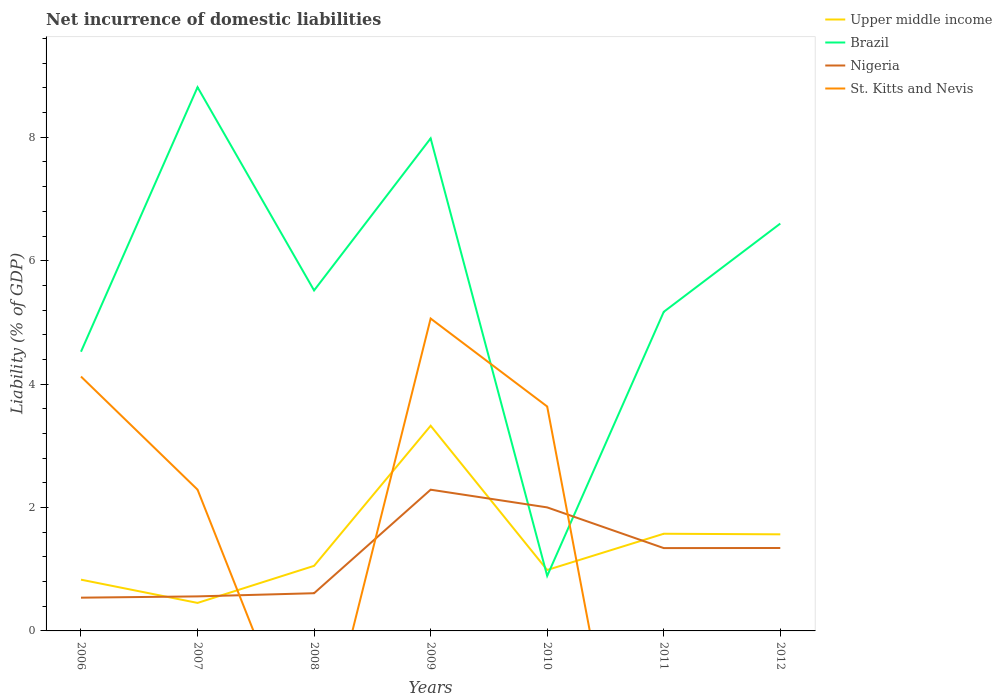Does the line corresponding to Nigeria intersect with the line corresponding to St. Kitts and Nevis?
Make the answer very short. Yes. Across all years, what is the maximum net incurrence of domestic liabilities in Upper middle income?
Offer a very short reply. 0.45. What is the total net incurrence of domestic liabilities in Brazil in the graph?
Provide a short and direct response. -1.08. What is the difference between the highest and the second highest net incurrence of domestic liabilities in Brazil?
Your response must be concise. 7.92. How many lines are there?
Offer a very short reply. 4. What is the difference between two consecutive major ticks on the Y-axis?
Your answer should be compact. 2. Are the values on the major ticks of Y-axis written in scientific E-notation?
Give a very brief answer. No. Does the graph contain grids?
Your answer should be very brief. No. How are the legend labels stacked?
Your answer should be very brief. Vertical. What is the title of the graph?
Ensure brevity in your answer.  Net incurrence of domestic liabilities. Does "Zambia" appear as one of the legend labels in the graph?
Ensure brevity in your answer.  No. What is the label or title of the X-axis?
Offer a terse response. Years. What is the label or title of the Y-axis?
Offer a very short reply. Liability (% of GDP). What is the Liability (% of GDP) of Upper middle income in 2006?
Keep it short and to the point. 0.83. What is the Liability (% of GDP) in Brazil in 2006?
Your response must be concise. 4.53. What is the Liability (% of GDP) in Nigeria in 2006?
Provide a short and direct response. 0.54. What is the Liability (% of GDP) in St. Kitts and Nevis in 2006?
Provide a succinct answer. 4.12. What is the Liability (% of GDP) in Upper middle income in 2007?
Offer a very short reply. 0.45. What is the Liability (% of GDP) of Brazil in 2007?
Keep it short and to the point. 8.81. What is the Liability (% of GDP) of Nigeria in 2007?
Provide a short and direct response. 0.56. What is the Liability (% of GDP) in St. Kitts and Nevis in 2007?
Provide a short and direct response. 2.29. What is the Liability (% of GDP) in Upper middle income in 2008?
Provide a short and direct response. 1.05. What is the Liability (% of GDP) of Brazil in 2008?
Ensure brevity in your answer.  5.52. What is the Liability (% of GDP) in Nigeria in 2008?
Offer a very short reply. 0.61. What is the Liability (% of GDP) of St. Kitts and Nevis in 2008?
Offer a very short reply. 0. What is the Liability (% of GDP) in Upper middle income in 2009?
Offer a terse response. 3.33. What is the Liability (% of GDP) in Brazil in 2009?
Offer a very short reply. 7.98. What is the Liability (% of GDP) in Nigeria in 2009?
Keep it short and to the point. 2.29. What is the Liability (% of GDP) of St. Kitts and Nevis in 2009?
Ensure brevity in your answer.  5.06. What is the Liability (% of GDP) of Upper middle income in 2010?
Offer a very short reply. 0.99. What is the Liability (% of GDP) of Brazil in 2010?
Offer a very short reply. 0.89. What is the Liability (% of GDP) in Nigeria in 2010?
Ensure brevity in your answer.  2. What is the Liability (% of GDP) of St. Kitts and Nevis in 2010?
Your answer should be very brief. 3.64. What is the Liability (% of GDP) of Upper middle income in 2011?
Give a very brief answer. 1.57. What is the Liability (% of GDP) in Brazil in 2011?
Offer a very short reply. 5.17. What is the Liability (% of GDP) in Nigeria in 2011?
Make the answer very short. 1.34. What is the Liability (% of GDP) of St. Kitts and Nevis in 2011?
Provide a succinct answer. 0. What is the Liability (% of GDP) of Upper middle income in 2012?
Provide a succinct answer. 1.57. What is the Liability (% of GDP) in Brazil in 2012?
Offer a very short reply. 6.6. What is the Liability (% of GDP) in Nigeria in 2012?
Provide a short and direct response. 1.34. Across all years, what is the maximum Liability (% of GDP) of Upper middle income?
Your answer should be compact. 3.33. Across all years, what is the maximum Liability (% of GDP) in Brazil?
Your answer should be very brief. 8.81. Across all years, what is the maximum Liability (% of GDP) of Nigeria?
Offer a terse response. 2.29. Across all years, what is the maximum Liability (% of GDP) in St. Kitts and Nevis?
Offer a terse response. 5.06. Across all years, what is the minimum Liability (% of GDP) in Upper middle income?
Make the answer very short. 0.45. Across all years, what is the minimum Liability (% of GDP) of Brazil?
Your response must be concise. 0.89. Across all years, what is the minimum Liability (% of GDP) of Nigeria?
Provide a succinct answer. 0.54. What is the total Liability (% of GDP) in Upper middle income in the graph?
Offer a terse response. 9.79. What is the total Liability (% of GDP) in Brazil in the graph?
Ensure brevity in your answer.  39.5. What is the total Liability (% of GDP) in Nigeria in the graph?
Give a very brief answer. 8.69. What is the total Liability (% of GDP) in St. Kitts and Nevis in the graph?
Your response must be concise. 15.11. What is the difference between the Liability (% of GDP) in Upper middle income in 2006 and that in 2007?
Your answer should be very brief. 0.38. What is the difference between the Liability (% of GDP) of Brazil in 2006 and that in 2007?
Your answer should be compact. -4.29. What is the difference between the Liability (% of GDP) of Nigeria in 2006 and that in 2007?
Give a very brief answer. -0.02. What is the difference between the Liability (% of GDP) in St. Kitts and Nevis in 2006 and that in 2007?
Your response must be concise. 1.83. What is the difference between the Liability (% of GDP) of Upper middle income in 2006 and that in 2008?
Make the answer very short. -0.22. What is the difference between the Liability (% of GDP) of Brazil in 2006 and that in 2008?
Offer a very short reply. -0.99. What is the difference between the Liability (% of GDP) in Nigeria in 2006 and that in 2008?
Provide a short and direct response. -0.07. What is the difference between the Liability (% of GDP) in Upper middle income in 2006 and that in 2009?
Offer a terse response. -2.49. What is the difference between the Liability (% of GDP) in Brazil in 2006 and that in 2009?
Give a very brief answer. -3.46. What is the difference between the Liability (% of GDP) in Nigeria in 2006 and that in 2009?
Offer a very short reply. -1.75. What is the difference between the Liability (% of GDP) of St. Kitts and Nevis in 2006 and that in 2009?
Your answer should be compact. -0.94. What is the difference between the Liability (% of GDP) of Upper middle income in 2006 and that in 2010?
Give a very brief answer. -0.16. What is the difference between the Liability (% of GDP) in Brazil in 2006 and that in 2010?
Your answer should be very brief. 3.63. What is the difference between the Liability (% of GDP) of Nigeria in 2006 and that in 2010?
Offer a terse response. -1.46. What is the difference between the Liability (% of GDP) of St. Kitts and Nevis in 2006 and that in 2010?
Your answer should be compact. 0.49. What is the difference between the Liability (% of GDP) in Upper middle income in 2006 and that in 2011?
Offer a very short reply. -0.74. What is the difference between the Liability (% of GDP) in Brazil in 2006 and that in 2011?
Offer a very short reply. -0.65. What is the difference between the Liability (% of GDP) in Nigeria in 2006 and that in 2011?
Your response must be concise. -0.8. What is the difference between the Liability (% of GDP) in Upper middle income in 2006 and that in 2012?
Provide a short and direct response. -0.73. What is the difference between the Liability (% of GDP) in Brazil in 2006 and that in 2012?
Ensure brevity in your answer.  -2.08. What is the difference between the Liability (% of GDP) of Nigeria in 2006 and that in 2012?
Give a very brief answer. -0.81. What is the difference between the Liability (% of GDP) in Upper middle income in 2007 and that in 2008?
Make the answer very short. -0.6. What is the difference between the Liability (% of GDP) of Brazil in 2007 and that in 2008?
Ensure brevity in your answer.  3.29. What is the difference between the Liability (% of GDP) of Nigeria in 2007 and that in 2008?
Offer a terse response. -0.05. What is the difference between the Liability (% of GDP) in Upper middle income in 2007 and that in 2009?
Your response must be concise. -2.87. What is the difference between the Liability (% of GDP) in Brazil in 2007 and that in 2009?
Provide a succinct answer. 0.83. What is the difference between the Liability (% of GDP) of Nigeria in 2007 and that in 2009?
Your answer should be very brief. -1.73. What is the difference between the Liability (% of GDP) in St. Kitts and Nevis in 2007 and that in 2009?
Your answer should be very brief. -2.77. What is the difference between the Liability (% of GDP) of Upper middle income in 2007 and that in 2010?
Your answer should be very brief. -0.53. What is the difference between the Liability (% of GDP) of Brazil in 2007 and that in 2010?
Give a very brief answer. 7.92. What is the difference between the Liability (% of GDP) in Nigeria in 2007 and that in 2010?
Provide a succinct answer. -1.44. What is the difference between the Liability (% of GDP) of St. Kitts and Nevis in 2007 and that in 2010?
Provide a succinct answer. -1.35. What is the difference between the Liability (% of GDP) of Upper middle income in 2007 and that in 2011?
Make the answer very short. -1.12. What is the difference between the Liability (% of GDP) in Brazil in 2007 and that in 2011?
Your answer should be compact. 3.64. What is the difference between the Liability (% of GDP) of Nigeria in 2007 and that in 2011?
Keep it short and to the point. -0.78. What is the difference between the Liability (% of GDP) in Upper middle income in 2007 and that in 2012?
Make the answer very short. -1.11. What is the difference between the Liability (% of GDP) in Brazil in 2007 and that in 2012?
Offer a terse response. 2.21. What is the difference between the Liability (% of GDP) in Nigeria in 2007 and that in 2012?
Make the answer very short. -0.78. What is the difference between the Liability (% of GDP) in Upper middle income in 2008 and that in 2009?
Your answer should be very brief. -2.27. What is the difference between the Liability (% of GDP) in Brazil in 2008 and that in 2009?
Your answer should be very brief. -2.46. What is the difference between the Liability (% of GDP) of Nigeria in 2008 and that in 2009?
Your answer should be compact. -1.68. What is the difference between the Liability (% of GDP) of Upper middle income in 2008 and that in 2010?
Give a very brief answer. 0.07. What is the difference between the Liability (% of GDP) in Brazil in 2008 and that in 2010?
Offer a terse response. 4.63. What is the difference between the Liability (% of GDP) of Nigeria in 2008 and that in 2010?
Ensure brevity in your answer.  -1.39. What is the difference between the Liability (% of GDP) of Upper middle income in 2008 and that in 2011?
Your response must be concise. -0.52. What is the difference between the Liability (% of GDP) of Brazil in 2008 and that in 2011?
Provide a succinct answer. 0.35. What is the difference between the Liability (% of GDP) of Nigeria in 2008 and that in 2011?
Offer a terse response. -0.73. What is the difference between the Liability (% of GDP) of Upper middle income in 2008 and that in 2012?
Your answer should be compact. -0.51. What is the difference between the Liability (% of GDP) of Brazil in 2008 and that in 2012?
Provide a succinct answer. -1.08. What is the difference between the Liability (% of GDP) of Nigeria in 2008 and that in 2012?
Give a very brief answer. -0.73. What is the difference between the Liability (% of GDP) in Upper middle income in 2009 and that in 2010?
Provide a short and direct response. 2.34. What is the difference between the Liability (% of GDP) of Brazil in 2009 and that in 2010?
Provide a short and direct response. 7.09. What is the difference between the Liability (% of GDP) of Nigeria in 2009 and that in 2010?
Provide a succinct answer. 0.29. What is the difference between the Liability (% of GDP) in St. Kitts and Nevis in 2009 and that in 2010?
Your answer should be very brief. 1.43. What is the difference between the Liability (% of GDP) in Upper middle income in 2009 and that in 2011?
Ensure brevity in your answer.  1.75. What is the difference between the Liability (% of GDP) in Brazil in 2009 and that in 2011?
Offer a terse response. 2.81. What is the difference between the Liability (% of GDP) in Nigeria in 2009 and that in 2011?
Give a very brief answer. 0.95. What is the difference between the Liability (% of GDP) in Upper middle income in 2009 and that in 2012?
Make the answer very short. 1.76. What is the difference between the Liability (% of GDP) in Brazil in 2009 and that in 2012?
Your answer should be very brief. 1.38. What is the difference between the Liability (% of GDP) in Nigeria in 2009 and that in 2012?
Make the answer very short. 0.94. What is the difference between the Liability (% of GDP) in Upper middle income in 2010 and that in 2011?
Provide a succinct answer. -0.59. What is the difference between the Liability (% of GDP) of Brazil in 2010 and that in 2011?
Ensure brevity in your answer.  -4.28. What is the difference between the Liability (% of GDP) of Nigeria in 2010 and that in 2011?
Make the answer very short. 0.66. What is the difference between the Liability (% of GDP) of Upper middle income in 2010 and that in 2012?
Make the answer very short. -0.58. What is the difference between the Liability (% of GDP) of Brazil in 2010 and that in 2012?
Offer a terse response. -5.71. What is the difference between the Liability (% of GDP) in Nigeria in 2010 and that in 2012?
Your response must be concise. 0.66. What is the difference between the Liability (% of GDP) in Upper middle income in 2011 and that in 2012?
Your response must be concise. 0.01. What is the difference between the Liability (% of GDP) of Brazil in 2011 and that in 2012?
Offer a very short reply. -1.43. What is the difference between the Liability (% of GDP) in Nigeria in 2011 and that in 2012?
Keep it short and to the point. -0. What is the difference between the Liability (% of GDP) of Upper middle income in 2006 and the Liability (% of GDP) of Brazil in 2007?
Keep it short and to the point. -7.98. What is the difference between the Liability (% of GDP) of Upper middle income in 2006 and the Liability (% of GDP) of Nigeria in 2007?
Keep it short and to the point. 0.27. What is the difference between the Liability (% of GDP) of Upper middle income in 2006 and the Liability (% of GDP) of St. Kitts and Nevis in 2007?
Provide a short and direct response. -1.46. What is the difference between the Liability (% of GDP) in Brazil in 2006 and the Liability (% of GDP) in Nigeria in 2007?
Keep it short and to the point. 3.97. What is the difference between the Liability (% of GDP) in Brazil in 2006 and the Liability (% of GDP) in St. Kitts and Nevis in 2007?
Provide a succinct answer. 2.24. What is the difference between the Liability (% of GDP) of Nigeria in 2006 and the Liability (% of GDP) of St. Kitts and Nevis in 2007?
Provide a succinct answer. -1.75. What is the difference between the Liability (% of GDP) in Upper middle income in 2006 and the Liability (% of GDP) in Brazil in 2008?
Keep it short and to the point. -4.69. What is the difference between the Liability (% of GDP) in Upper middle income in 2006 and the Liability (% of GDP) in Nigeria in 2008?
Keep it short and to the point. 0.22. What is the difference between the Liability (% of GDP) of Brazil in 2006 and the Liability (% of GDP) of Nigeria in 2008?
Offer a terse response. 3.91. What is the difference between the Liability (% of GDP) in Upper middle income in 2006 and the Liability (% of GDP) in Brazil in 2009?
Offer a very short reply. -7.15. What is the difference between the Liability (% of GDP) of Upper middle income in 2006 and the Liability (% of GDP) of Nigeria in 2009?
Ensure brevity in your answer.  -1.46. What is the difference between the Liability (% of GDP) in Upper middle income in 2006 and the Liability (% of GDP) in St. Kitts and Nevis in 2009?
Give a very brief answer. -4.23. What is the difference between the Liability (% of GDP) in Brazil in 2006 and the Liability (% of GDP) in Nigeria in 2009?
Provide a short and direct response. 2.24. What is the difference between the Liability (% of GDP) in Brazil in 2006 and the Liability (% of GDP) in St. Kitts and Nevis in 2009?
Provide a short and direct response. -0.54. What is the difference between the Liability (% of GDP) of Nigeria in 2006 and the Liability (% of GDP) of St. Kitts and Nevis in 2009?
Offer a very short reply. -4.52. What is the difference between the Liability (% of GDP) in Upper middle income in 2006 and the Liability (% of GDP) in Brazil in 2010?
Your response must be concise. -0.06. What is the difference between the Liability (% of GDP) of Upper middle income in 2006 and the Liability (% of GDP) of Nigeria in 2010?
Provide a succinct answer. -1.17. What is the difference between the Liability (% of GDP) of Upper middle income in 2006 and the Liability (% of GDP) of St. Kitts and Nevis in 2010?
Provide a succinct answer. -2.81. What is the difference between the Liability (% of GDP) in Brazil in 2006 and the Liability (% of GDP) in Nigeria in 2010?
Provide a short and direct response. 2.52. What is the difference between the Liability (% of GDP) of Brazil in 2006 and the Liability (% of GDP) of St. Kitts and Nevis in 2010?
Provide a short and direct response. 0.89. What is the difference between the Liability (% of GDP) of Nigeria in 2006 and the Liability (% of GDP) of St. Kitts and Nevis in 2010?
Your answer should be compact. -3.1. What is the difference between the Liability (% of GDP) of Upper middle income in 2006 and the Liability (% of GDP) of Brazil in 2011?
Provide a short and direct response. -4.34. What is the difference between the Liability (% of GDP) of Upper middle income in 2006 and the Liability (% of GDP) of Nigeria in 2011?
Your response must be concise. -0.51. What is the difference between the Liability (% of GDP) in Brazil in 2006 and the Liability (% of GDP) in Nigeria in 2011?
Your answer should be very brief. 3.18. What is the difference between the Liability (% of GDP) in Upper middle income in 2006 and the Liability (% of GDP) in Brazil in 2012?
Your answer should be compact. -5.77. What is the difference between the Liability (% of GDP) of Upper middle income in 2006 and the Liability (% of GDP) of Nigeria in 2012?
Keep it short and to the point. -0.51. What is the difference between the Liability (% of GDP) of Brazil in 2006 and the Liability (% of GDP) of Nigeria in 2012?
Offer a terse response. 3.18. What is the difference between the Liability (% of GDP) of Upper middle income in 2007 and the Liability (% of GDP) of Brazil in 2008?
Provide a short and direct response. -5.06. What is the difference between the Liability (% of GDP) of Upper middle income in 2007 and the Liability (% of GDP) of Nigeria in 2008?
Make the answer very short. -0.16. What is the difference between the Liability (% of GDP) of Brazil in 2007 and the Liability (% of GDP) of Nigeria in 2008?
Provide a short and direct response. 8.2. What is the difference between the Liability (% of GDP) of Upper middle income in 2007 and the Liability (% of GDP) of Brazil in 2009?
Keep it short and to the point. -7.53. What is the difference between the Liability (% of GDP) of Upper middle income in 2007 and the Liability (% of GDP) of Nigeria in 2009?
Keep it short and to the point. -1.83. What is the difference between the Liability (% of GDP) of Upper middle income in 2007 and the Liability (% of GDP) of St. Kitts and Nevis in 2009?
Keep it short and to the point. -4.61. What is the difference between the Liability (% of GDP) in Brazil in 2007 and the Liability (% of GDP) in Nigeria in 2009?
Make the answer very short. 6.52. What is the difference between the Liability (% of GDP) of Brazil in 2007 and the Liability (% of GDP) of St. Kitts and Nevis in 2009?
Give a very brief answer. 3.75. What is the difference between the Liability (% of GDP) in Nigeria in 2007 and the Liability (% of GDP) in St. Kitts and Nevis in 2009?
Give a very brief answer. -4.5. What is the difference between the Liability (% of GDP) in Upper middle income in 2007 and the Liability (% of GDP) in Brazil in 2010?
Ensure brevity in your answer.  -0.44. What is the difference between the Liability (% of GDP) of Upper middle income in 2007 and the Liability (% of GDP) of Nigeria in 2010?
Your answer should be very brief. -1.55. What is the difference between the Liability (% of GDP) of Upper middle income in 2007 and the Liability (% of GDP) of St. Kitts and Nevis in 2010?
Make the answer very short. -3.18. What is the difference between the Liability (% of GDP) of Brazil in 2007 and the Liability (% of GDP) of Nigeria in 2010?
Keep it short and to the point. 6.81. What is the difference between the Liability (% of GDP) in Brazil in 2007 and the Liability (% of GDP) in St. Kitts and Nevis in 2010?
Keep it short and to the point. 5.17. What is the difference between the Liability (% of GDP) in Nigeria in 2007 and the Liability (% of GDP) in St. Kitts and Nevis in 2010?
Your answer should be very brief. -3.08. What is the difference between the Liability (% of GDP) of Upper middle income in 2007 and the Liability (% of GDP) of Brazil in 2011?
Provide a short and direct response. -4.72. What is the difference between the Liability (% of GDP) of Upper middle income in 2007 and the Liability (% of GDP) of Nigeria in 2011?
Ensure brevity in your answer.  -0.89. What is the difference between the Liability (% of GDP) of Brazil in 2007 and the Liability (% of GDP) of Nigeria in 2011?
Your answer should be very brief. 7.47. What is the difference between the Liability (% of GDP) of Upper middle income in 2007 and the Liability (% of GDP) of Brazil in 2012?
Give a very brief answer. -6.15. What is the difference between the Liability (% of GDP) of Upper middle income in 2007 and the Liability (% of GDP) of Nigeria in 2012?
Give a very brief answer. -0.89. What is the difference between the Liability (% of GDP) in Brazil in 2007 and the Liability (% of GDP) in Nigeria in 2012?
Keep it short and to the point. 7.47. What is the difference between the Liability (% of GDP) in Upper middle income in 2008 and the Liability (% of GDP) in Brazil in 2009?
Your answer should be very brief. -6.93. What is the difference between the Liability (% of GDP) in Upper middle income in 2008 and the Liability (% of GDP) in Nigeria in 2009?
Offer a terse response. -1.23. What is the difference between the Liability (% of GDP) of Upper middle income in 2008 and the Liability (% of GDP) of St. Kitts and Nevis in 2009?
Offer a terse response. -4.01. What is the difference between the Liability (% of GDP) in Brazil in 2008 and the Liability (% of GDP) in Nigeria in 2009?
Give a very brief answer. 3.23. What is the difference between the Liability (% of GDP) of Brazil in 2008 and the Liability (% of GDP) of St. Kitts and Nevis in 2009?
Keep it short and to the point. 0.46. What is the difference between the Liability (% of GDP) in Nigeria in 2008 and the Liability (% of GDP) in St. Kitts and Nevis in 2009?
Offer a terse response. -4.45. What is the difference between the Liability (% of GDP) in Upper middle income in 2008 and the Liability (% of GDP) in Brazil in 2010?
Offer a terse response. 0.16. What is the difference between the Liability (% of GDP) in Upper middle income in 2008 and the Liability (% of GDP) in Nigeria in 2010?
Your response must be concise. -0.95. What is the difference between the Liability (% of GDP) of Upper middle income in 2008 and the Liability (% of GDP) of St. Kitts and Nevis in 2010?
Make the answer very short. -2.58. What is the difference between the Liability (% of GDP) of Brazil in 2008 and the Liability (% of GDP) of Nigeria in 2010?
Give a very brief answer. 3.52. What is the difference between the Liability (% of GDP) in Brazil in 2008 and the Liability (% of GDP) in St. Kitts and Nevis in 2010?
Provide a succinct answer. 1.88. What is the difference between the Liability (% of GDP) in Nigeria in 2008 and the Liability (% of GDP) in St. Kitts and Nevis in 2010?
Your response must be concise. -3.03. What is the difference between the Liability (% of GDP) of Upper middle income in 2008 and the Liability (% of GDP) of Brazil in 2011?
Your answer should be compact. -4.12. What is the difference between the Liability (% of GDP) in Upper middle income in 2008 and the Liability (% of GDP) in Nigeria in 2011?
Your answer should be compact. -0.29. What is the difference between the Liability (% of GDP) in Brazil in 2008 and the Liability (% of GDP) in Nigeria in 2011?
Give a very brief answer. 4.18. What is the difference between the Liability (% of GDP) in Upper middle income in 2008 and the Liability (% of GDP) in Brazil in 2012?
Provide a succinct answer. -5.55. What is the difference between the Liability (% of GDP) of Upper middle income in 2008 and the Liability (% of GDP) of Nigeria in 2012?
Your answer should be compact. -0.29. What is the difference between the Liability (% of GDP) in Brazil in 2008 and the Liability (% of GDP) in Nigeria in 2012?
Ensure brevity in your answer.  4.17. What is the difference between the Liability (% of GDP) in Upper middle income in 2009 and the Liability (% of GDP) in Brazil in 2010?
Offer a very short reply. 2.43. What is the difference between the Liability (% of GDP) in Upper middle income in 2009 and the Liability (% of GDP) in Nigeria in 2010?
Provide a succinct answer. 1.32. What is the difference between the Liability (% of GDP) of Upper middle income in 2009 and the Liability (% of GDP) of St. Kitts and Nevis in 2010?
Provide a succinct answer. -0.31. What is the difference between the Liability (% of GDP) in Brazil in 2009 and the Liability (% of GDP) in Nigeria in 2010?
Keep it short and to the point. 5.98. What is the difference between the Liability (% of GDP) of Brazil in 2009 and the Liability (% of GDP) of St. Kitts and Nevis in 2010?
Your answer should be compact. 4.35. What is the difference between the Liability (% of GDP) of Nigeria in 2009 and the Liability (% of GDP) of St. Kitts and Nevis in 2010?
Provide a short and direct response. -1.35. What is the difference between the Liability (% of GDP) in Upper middle income in 2009 and the Liability (% of GDP) in Brazil in 2011?
Your answer should be compact. -1.85. What is the difference between the Liability (% of GDP) in Upper middle income in 2009 and the Liability (% of GDP) in Nigeria in 2011?
Your response must be concise. 1.98. What is the difference between the Liability (% of GDP) in Brazil in 2009 and the Liability (% of GDP) in Nigeria in 2011?
Keep it short and to the point. 6.64. What is the difference between the Liability (% of GDP) of Upper middle income in 2009 and the Liability (% of GDP) of Brazil in 2012?
Your response must be concise. -3.28. What is the difference between the Liability (% of GDP) in Upper middle income in 2009 and the Liability (% of GDP) in Nigeria in 2012?
Your answer should be very brief. 1.98. What is the difference between the Liability (% of GDP) in Brazil in 2009 and the Liability (% of GDP) in Nigeria in 2012?
Keep it short and to the point. 6.64. What is the difference between the Liability (% of GDP) of Upper middle income in 2010 and the Liability (% of GDP) of Brazil in 2011?
Provide a succinct answer. -4.18. What is the difference between the Liability (% of GDP) of Upper middle income in 2010 and the Liability (% of GDP) of Nigeria in 2011?
Make the answer very short. -0.35. What is the difference between the Liability (% of GDP) of Brazil in 2010 and the Liability (% of GDP) of Nigeria in 2011?
Give a very brief answer. -0.45. What is the difference between the Liability (% of GDP) of Upper middle income in 2010 and the Liability (% of GDP) of Brazil in 2012?
Offer a terse response. -5.61. What is the difference between the Liability (% of GDP) of Upper middle income in 2010 and the Liability (% of GDP) of Nigeria in 2012?
Your answer should be very brief. -0.36. What is the difference between the Liability (% of GDP) of Brazil in 2010 and the Liability (% of GDP) of Nigeria in 2012?
Make the answer very short. -0.45. What is the difference between the Liability (% of GDP) of Upper middle income in 2011 and the Liability (% of GDP) of Brazil in 2012?
Offer a terse response. -5.03. What is the difference between the Liability (% of GDP) in Upper middle income in 2011 and the Liability (% of GDP) in Nigeria in 2012?
Offer a very short reply. 0.23. What is the difference between the Liability (% of GDP) in Brazil in 2011 and the Liability (% of GDP) in Nigeria in 2012?
Your answer should be compact. 3.83. What is the average Liability (% of GDP) of Upper middle income per year?
Keep it short and to the point. 1.4. What is the average Liability (% of GDP) in Brazil per year?
Make the answer very short. 5.64. What is the average Liability (% of GDP) of Nigeria per year?
Make the answer very short. 1.24. What is the average Liability (% of GDP) in St. Kitts and Nevis per year?
Provide a succinct answer. 2.16. In the year 2006, what is the difference between the Liability (% of GDP) of Upper middle income and Liability (% of GDP) of Brazil?
Your response must be concise. -3.69. In the year 2006, what is the difference between the Liability (% of GDP) in Upper middle income and Liability (% of GDP) in Nigeria?
Offer a terse response. 0.29. In the year 2006, what is the difference between the Liability (% of GDP) of Upper middle income and Liability (% of GDP) of St. Kitts and Nevis?
Your answer should be compact. -3.29. In the year 2006, what is the difference between the Liability (% of GDP) of Brazil and Liability (% of GDP) of Nigeria?
Provide a short and direct response. 3.99. In the year 2006, what is the difference between the Liability (% of GDP) of Brazil and Liability (% of GDP) of St. Kitts and Nevis?
Your response must be concise. 0.4. In the year 2006, what is the difference between the Liability (% of GDP) in Nigeria and Liability (% of GDP) in St. Kitts and Nevis?
Keep it short and to the point. -3.58. In the year 2007, what is the difference between the Liability (% of GDP) in Upper middle income and Liability (% of GDP) in Brazil?
Offer a terse response. -8.36. In the year 2007, what is the difference between the Liability (% of GDP) in Upper middle income and Liability (% of GDP) in Nigeria?
Provide a succinct answer. -0.11. In the year 2007, what is the difference between the Liability (% of GDP) of Upper middle income and Liability (% of GDP) of St. Kitts and Nevis?
Your answer should be compact. -1.84. In the year 2007, what is the difference between the Liability (% of GDP) in Brazil and Liability (% of GDP) in Nigeria?
Keep it short and to the point. 8.25. In the year 2007, what is the difference between the Liability (% of GDP) of Brazil and Liability (% of GDP) of St. Kitts and Nevis?
Make the answer very short. 6.52. In the year 2007, what is the difference between the Liability (% of GDP) of Nigeria and Liability (% of GDP) of St. Kitts and Nevis?
Provide a succinct answer. -1.73. In the year 2008, what is the difference between the Liability (% of GDP) in Upper middle income and Liability (% of GDP) in Brazil?
Provide a short and direct response. -4.46. In the year 2008, what is the difference between the Liability (% of GDP) of Upper middle income and Liability (% of GDP) of Nigeria?
Give a very brief answer. 0.44. In the year 2008, what is the difference between the Liability (% of GDP) of Brazil and Liability (% of GDP) of Nigeria?
Give a very brief answer. 4.91. In the year 2009, what is the difference between the Liability (% of GDP) of Upper middle income and Liability (% of GDP) of Brazil?
Offer a terse response. -4.66. In the year 2009, what is the difference between the Liability (% of GDP) of Upper middle income and Liability (% of GDP) of Nigeria?
Make the answer very short. 1.04. In the year 2009, what is the difference between the Liability (% of GDP) in Upper middle income and Liability (% of GDP) in St. Kitts and Nevis?
Ensure brevity in your answer.  -1.74. In the year 2009, what is the difference between the Liability (% of GDP) of Brazil and Liability (% of GDP) of Nigeria?
Your answer should be compact. 5.69. In the year 2009, what is the difference between the Liability (% of GDP) of Brazil and Liability (% of GDP) of St. Kitts and Nevis?
Your response must be concise. 2.92. In the year 2009, what is the difference between the Liability (% of GDP) of Nigeria and Liability (% of GDP) of St. Kitts and Nevis?
Make the answer very short. -2.77. In the year 2010, what is the difference between the Liability (% of GDP) of Upper middle income and Liability (% of GDP) of Brazil?
Give a very brief answer. 0.1. In the year 2010, what is the difference between the Liability (% of GDP) of Upper middle income and Liability (% of GDP) of Nigeria?
Ensure brevity in your answer.  -1.01. In the year 2010, what is the difference between the Liability (% of GDP) of Upper middle income and Liability (% of GDP) of St. Kitts and Nevis?
Your answer should be compact. -2.65. In the year 2010, what is the difference between the Liability (% of GDP) of Brazil and Liability (% of GDP) of Nigeria?
Your answer should be compact. -1.11. In the year 2010, what is the difference between the Liability (% of GDP) in Brazil and Liability (% of GDP) in St. Kitts and Nevis?
Ensure brevity in your answer.  -2.75. In the year 2010, what is the difference between the Liability (% of GDP) of Nigeria and Liability (% of GDP) of St. Kitts and Nevis?
Ensure brevity in your answer.  -1.64. In the year 2011, what is the difference between the Liability (% of GDP) of Upper middle income and Liability (% of GDP) of Brazil?
Your answer should be very brief. -3.6. In the year 2011, what is the difference between the Liability (% of GDP) of Upper middle income and Liability (% of GDP) of Nigeria?
Keep it short and to the point. 0.23. In the year 2011, what is the difference between the Liability (% of GDP) in Brazil and Liability (% of GDP) in Nigeria?
Offer a terse response. 3.83. In the year 2012, what is the difference between the Liability (% of GDP) in Upper middle income and Liability (% of GDP) in Brazil?
Offer a terse response. -5.04. In the year 2012, what is the difference between the Liability (% of GDP) in Upper middle income and Liability (% of GDP) in Nigeria?
Give a very brief answer. 0.22. In the year 2012, what is the difference between the Liability (% of GDP) in Brazil and Liability (% of GDP) in Nigeria?
Offer a very short reply. 5.26. What is the ratio of the Liability (% of GDP) of Upper middle income in 2006 to that in 2007?
Make the answer very short. 1.83. What is the ratio of the Liability (% of GDP) in Brazil in 2006 to that in 2007?
Offer a terse response. 0.51. What is the ratio of the Liability (% of GDP) in Nigeria in 2006 to that in 2007?
Your response must be concise. 0.96. What is the ratio of the Liability (% of GDP) in St. Kitts and Nevis in 2006 to that in 2007?
Offer a terse response. 1.8. What is the ratio of the Liability (% of GDP) in Upper middle income in 2006 to that in 2008?
Offer a very short reply. 0.79. What is the ratio of the Liability (% of GDP) in Brazil in 2006 to that in 2008?
Offer a terse response. 0.82. What is the ratio of the Liability (% of GDP) of Nigeria in 2006 to that in 2008?
Give a very brief answer. 0.88. What is the ratio of the Liability (% of GDP) in Upper middle income in 2006 to that in 2009?
Provide a succinct answer. 0.25. What is the ratio of the Liability (% of GDP) in Brazil in 2006 to that in 2009?
Your response must be concise. 0.57. What is the ratio of the Liability (% of GDP) in Nigeria in 2006 to that in 2009?
Provide a short and direct response. 0.24. What is the ratio of the Liability (% of GDP) in St. Kitts and Nevis in 2006 to that in 2009?
Offer a terse response. 0.81. What is the ratio of the Liability (% of GDP) in Upper middle income in 2006 to that in 2010?
Your response must be concise. 0.84. What is the ratio of the Liability (% of GDP) in Brazil in 2006 to that in 2010?
Make the answer very short. 5.07. What is the ratio of the Liability (% of GDP) in Nigeria in 2006 to that in 2010?
Ensure brevity in your answer.  0.27. What is the ratio of the Liability (% of GDP) in St. Kitts and Nevis in 2006 to that in 2010?
Your answer should be very brief. 1.13. What is the ratio of the Liability (% of GDP) in Upper middle income in 2006 to that in 2011?
Provide a short and direct response. 0.53. What is the ratio of the Liability (% of GDP) in Brazil in 2006 to that in 2011?
Your response must be concise. 0.88. What is the ratio of the Liability (% of GDP) in Nigeria in 2006 to that in 2011?
Provide a succinct answer. 0.4. What is the ratio of the Liability (% of GDP) of Upper middle income in 2006 to that in 2012?
Provide a short and direct response. 0.53. What is the ratio of the Liability (% of GDP) in Brazil in 2006 to that in 2012?
Ensure brevity in your answer.  0.69. What is the ratio of the Liability (% of GDP) in Nigeria in 2006 to that in 2012?
Your answer should be very brief. 0.4. What is the ratio of the Liability (% of GDP) in Upper middle income in 2007 to that in 2008?
Offer a very short reply. 0.43. What is the ratio of the Liability (% of GDP) of Brazil in 2007 to that in 2008?
Ensure brevity in your answer.  1.6. What is the ratio of the Liability (% of GDP) in Nigeria in 2007 to that in 2008?
Provide a short and direct response. 0.92. What is the ratio of the Liability (% of GDP) in Upper middle income in 2007 to that in 2009?
Your answer should be very brief. 0.14. What is the ratio of the Liability (% of GDP) in Brazil in 2007 to that in 2009?
Your response must be concise. 1.1. What is the ratio of the Liability (% of GDP) in Nigeria in 2007 to that in 2009?
Provide a succinct answer. 0.24. What is the ratio of the Liability (% of GDP) of St. Kitts and Nevis in 2007 to that in 2009?
Offer a terse response. 0.45. What is the ratio of the Liability (% of GDP) in Upper middle income in 2007 to that in 2010?
Ensure brevity in your answer.  0.46. What is the ratio of the Liability (% of GDP) of Brazil in 2007 to that in 2010?
Your response must be concise. 9.88. What is the ratio of the Liability (% of GDP) of Nigeria in 2007 to that in 2010?
Offer a terse response. 0.28. What is the ratio of the Liability (% of GDP) in St. Kitts and Nevis in 2007 to that in 2010?
Your response must be concise. 0.63. What is the ratio of the Liability (% of GDP) of Upper middle income in 2007 to that in 2011?
Offer a very short reply. 0.29. What is the ratio of the Liability (% of GDP) of Brazil in 2007 to that in 2011?
Make the answer very short. 1.7. What is the ratio of the Liability (% of GDP) in Nigeria in 2007 to that in 2011?
Your answer should be very brief. 0.42. What is the ratio of the Liability (% of GDP) of Upper middle income in 2007 to that in 2012?
Give a very brief answer. 0.29. What is the ratio of the Liability (% of GDP) of Brazil in 2007 to that in 2012?
Provide a short and direct response. 1.33. What is the ratio of the Liability (% of GDP) in Nigeria in 2007 to that in 2012?
Offer a very short reply. 0.42. What is the ratio of the Liability (% of GDP) in Upper middle income in 2008 to that in 2009?
Your answer should be very brief. 0.32. What is the ratio of the Liability (% of GDP) of Brazil in 2008 to that in 2009?
Offer a terse response. 0.69. What is the ratio of the Liability (% of GDP) in Nigeria in 2008 to that in 2009?
Your answer should be very brief. 0.27. What is the ratio of the Liability (% of GDP) of Upper middle income in 2008 to that in 2010?
Provide a succinct answer. 1.07. What is the ratio of the Liability (% of GDP) of Brazil in 2008 to that in 2010?
Keep it short and to the point. 6.19. What is the ratio of the Liability (% of GDP) of Nigeria in 2008 to that in 2010?
Offer a very short reply. 0.31. What is the ratio of the Liability (% of GDP) of Upper middle income in 2008 to that in 2011?
Give a very brief answer. 0.67. What is the ratio of the Liability (% of GDP) of Brazil in 2008 to that in 2011?
Your answer should be compact. 1.07. What is the ratio of the Liability (% of GDP) of Nigeria in 2008 to that in 2011?
Your response must be concise. 0.46. What is the ratio of the Liability (% of GDP) of Upper middle income in 2008 to that in 2012?
Your answer should be compact. 0.67. What is the ratio of the Liability (% of GDP) of Brazil in 2008 to that in 2012?
Provide a succinct answer. 0.84. What is the ratio of the Liability (% of GDP) in Nigeria in 2008 to that in 2012?
Your answer should be compact. 0.45. What is the ratio of the Liability (% of GDP) of Upper middle income in 2009 to that in 2010?
Offer a very short reply. 3.37. What is the ratio of the Liability (% of GDP) of Brazil in 2009 to that in 2010?
Give a very brief answer. 8.95. What is the ratio of the Liability (% of GDP) in Nigeria in 2009 to that in 2010?
Keep it short and to the point. 1.14. What is the ratio of the Liability (% of GDP) of St. Kitts and Nevis in 2009 to that in 2010?
Your answer should be compact. 1.39. What is the ratio of the Liability (% of GDP) of Upper middle income in 2009 to that in 2011?
Make the answer very short. 2.11. What is the ratio of the Liability (% of GDP) of Brazil in 2009 to that in 2011?
Make the answer very short. 1.54. What is the ratio of the Liability (% of GDP) of Nigeria in 2009 to that in 2011?
Your answer should be very brief. 1.71. What is the ratio of the Liability (% of GDP) of Upper middle income in 2009 to that in 2012?
Your answer should be compact. 2.12. What is the ratio of the Liability (% of GDP) of Brazil in 2009 to that in 2012?
Your answer should be very brief. 1.21. What is the ratio of the Liability (% of GDP) in Nigeria in 2009 to that in 2012?
Provide a short and direct response. 1.7. What is the ratio of the Liability (% of GDP) in Upper middle income in 2010 to that in 2011?
Offer a terse response. 0.63. What is the ratio of the Liability (% of GDP) in Brazil in 2010 to that in 2011?
Your answer should be very brief. 0.17. What is the ratio of the Liability (% of GDP) in Nigeria in 2010 to that in 2011?
Your answer should be very brief. 1.49. What is the ratio of the Liability (% of GDP) in Upper middle income in 2010 to that in 2012?
Provide a succinct answer. 0.63. What is the ratio of the Liability (% of GDP) of Brazil in 2010 to that in 2012?
Offer a very short reply. 0.14. What is the ratio of the Liability (% of GDP) in Nigeria in 2010 to that in 2012?
Your answer should be compact. 1.49. What is the ratio of the Liability (% of GDP) of Upper middle income in 2011 to that in 2012?
Make the answer very short. 1.01. What is the ratio of the Liability (% of GDP) of Brazil in 2011 to that in 2012?
Make the answer very short. 0.78. What is the difference between the highest and the second highest Liability (% of GDP) in Upper middle income?
Your answer should be very brief. 1.75. What is the difference between the highest and the second highest Liability (% of GDP) of Brazil?
Provide a succinct answer. 0.83. What is the difference between the highest and the second highest Liability (% of GDP) in Nigeria?
Make the answer very short. 0.29. What is the difference between the highest and the second highest Liability (% of GDP) in St. Kitts and Nevis?
Offer a very short reply. 0.94. What is the difference between the highest and the lowest Liability (% of GDP) in Upper middle income?
Ensure brevity in your answer.  2.87. What is the difference between the highest and the lowest Liability (% of GDP) of Brazil?
Your answer should be very brief. 7.92. What is the difference between the highest and the lowest Liability (% of GDP) of Nigeria?
Provide a succinct answer. 1.75. What is the difference between the highest and the lowest Liability (% of GDP) in St. Kitts and Nevis?
Give a very brief answer. 5.06. 